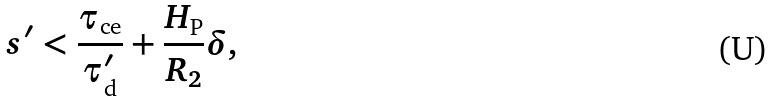Convert formula to latex. <formula><loc_0><loc_0><loc_500><loc_500>s ^ { \prime } < \frac { \tau _ { \text {ce} } } { \tau ^ { \prime } _ { \text {d} } } + \frac { H _ { \text {P} } } { R _ { 2 } } \delta ,</formula> 